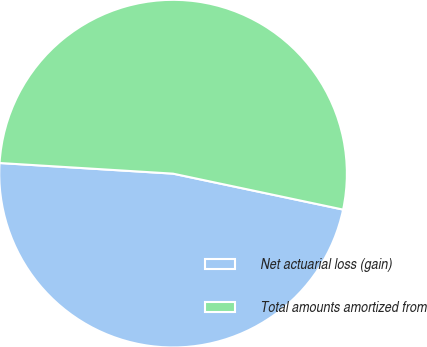Convert chart to OTSL. <chart><loc_0><loc_0><loc_500><loc_500><pie_chart><fcel>Net actuarial loss (gain)<fcel>Total amounts amortized from<nl><fcel>47.66%<fcel>52.34%<nl></chart> 